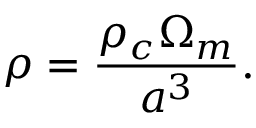Convert formula to latex. <formula><loc_0><loc_0><loc_500><loc_500>\rho = { \frac { \rho _ { c } \Omega _ { m } } { a ^ { 3 } } } .</formula> 